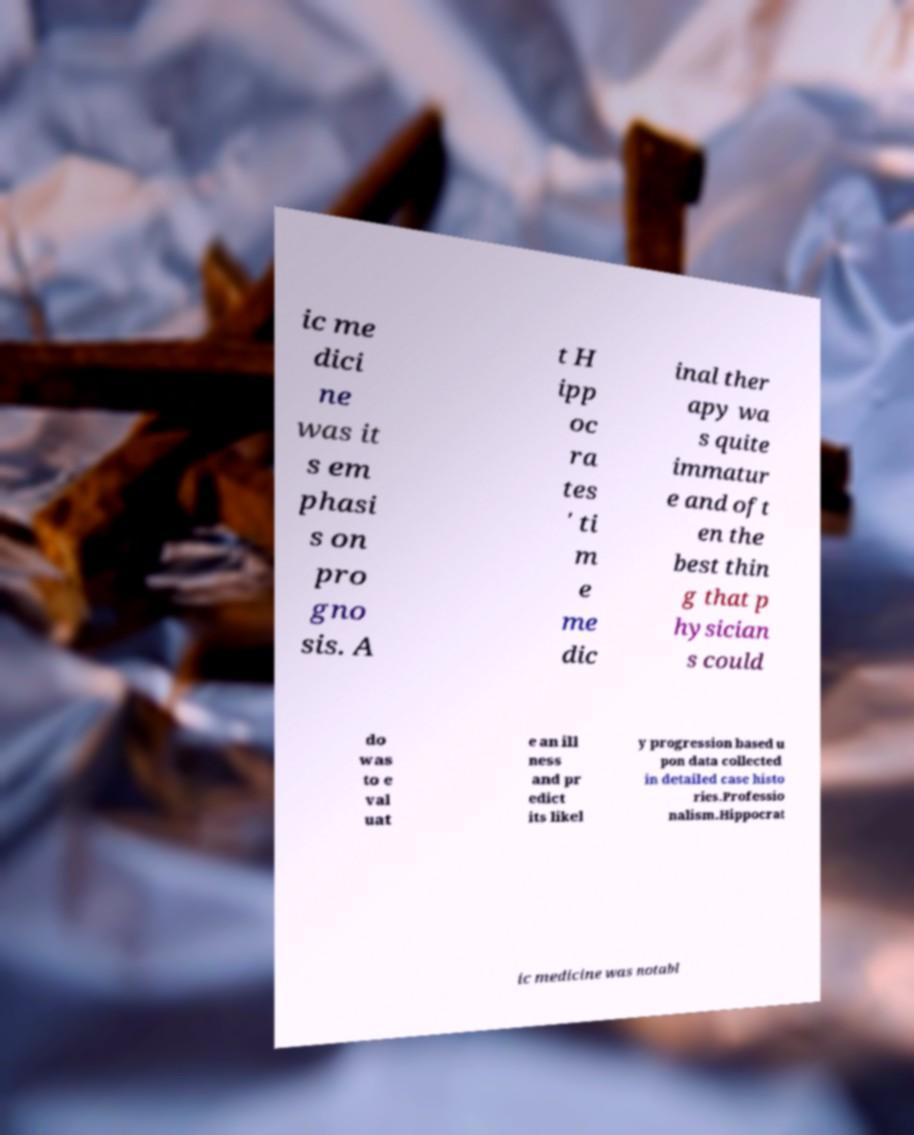I need the written content from this picture converted into text. Can you do that? ic me dici ne was it s em phasi s on pro gno sis. A t H ipp oc ra tes ' ti m e me dic inal ther apy wa s quite immatur e and oft en the best thin g that p hysician s could do was to e val uat e an ill ness and pr edict its likel y progression based u pon data collected in detailed case histo ries.Professio nalism.Hippocrat ic medicine was notabl 